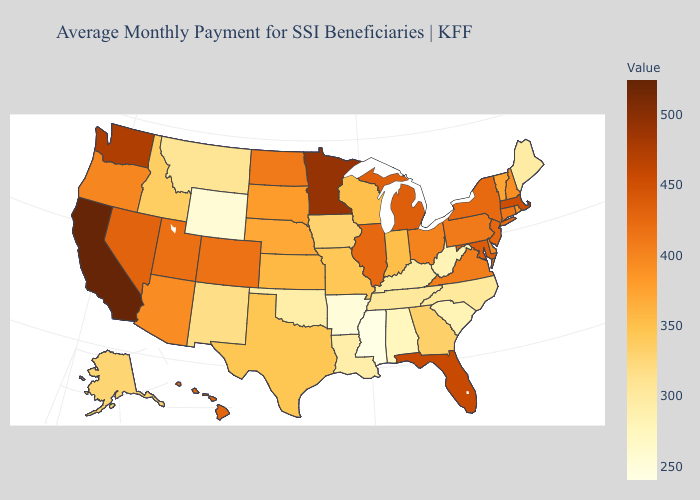Among the states that border Indiana , does Kentucky have the lowest value?
Be succinct. Yes. Does Florida have the highest value in the South?
Answer briefly. Yes. Which states have the highest value in the USA?
Give a very brief answer. California. Does California have the highest value in the USA?
Concise answer only. Yes. Which states hav the highest value in the MidWest?
Concise answer only. Minnesota. 